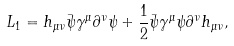Convert formula to latex. <formula><loc_0><loc_0><loc_500><loc_500>L _ { 1 } = h _ { \mu \nu } \bar { \psi } \gamma ^ { \mu } \partial ^ { \nu } \psi + \frac { 1 } { 2 } \bar { \psi } \gamma ^ { \mu } \psi \partial ^ { \nu } h _ { \mu \nu } ,</formula> 